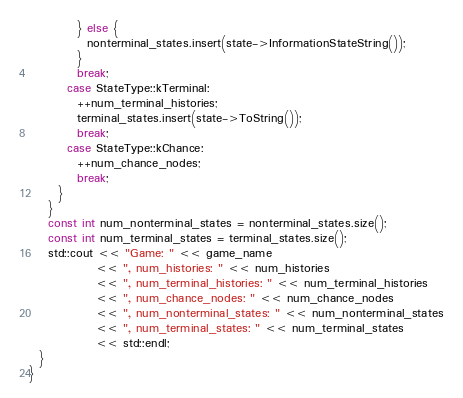<code> <loc_0><loc_0><loc_500><loc_500><_C++_>          } else {
            nonterminal_states.insert(state->InformationStateString());
          }
          break;
        case StateType::kTerminal:
          ++num_terminal_histories;
          terminal_states.insert(state->ToString());
          break;
        case StateType::kChance:
          ++num_chance_nodes;
          break;
      }
    }
    const int num_nonterminal_states = nonterminal_states.size();
    const int num_terminal_states = terminal_states.size();
    std::cout << "Game: " << game_name
              << ", num_histories: " << num_histories
              << ", num_terminal_histories: " << num_terminal_histories
              << ", num_chance_nodes: " << num_chance_nodes
              << ", num_nonterminal_states: " << num_nonterminal_states
              << ", num_terminal_states: " << num_terminal_states
              << std::endl;
  }
}
</code> 